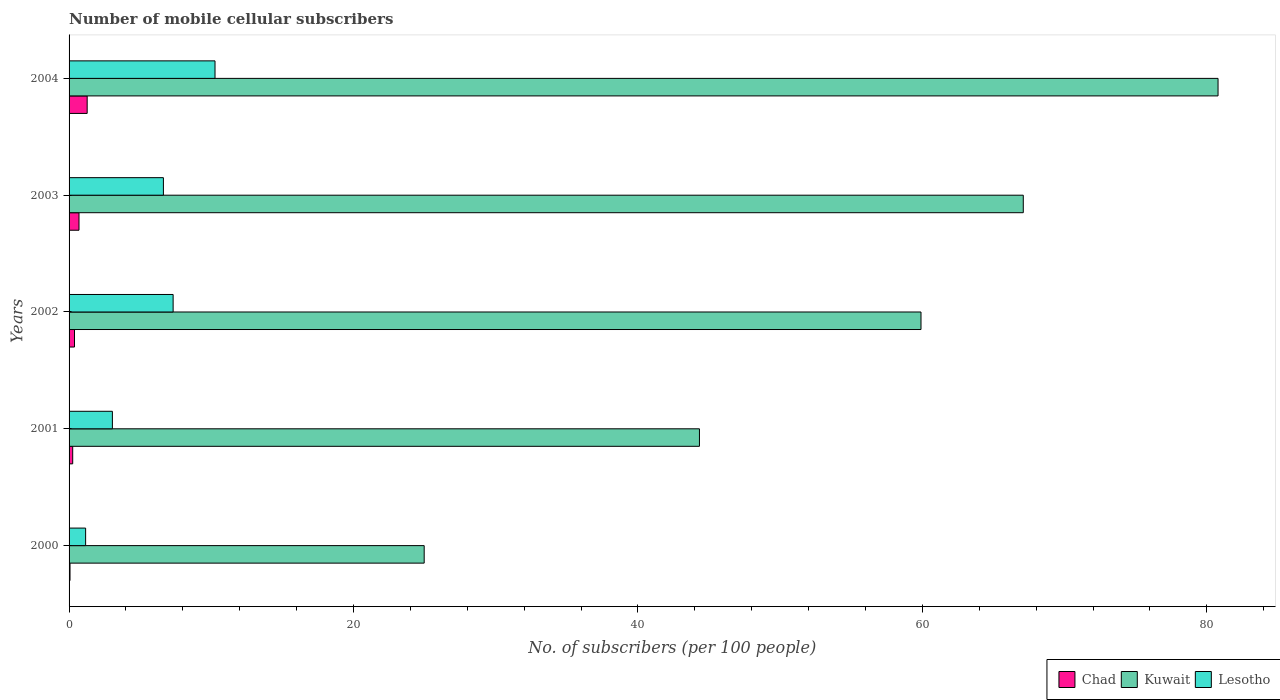How many groups of bars are there?
Offer a terse response. 5. Are the number of bars per tick equal to the number of legend labels?
Make the answer very short. Yes. Are the number of bars on each tick of the Y-axis equal?
Your response must be concise. Yes. How many bars are there on the 3rd tick from the top?
Your answer should be very brief. 3. How many bars are there on the 4th tick from the bottom?
Ensure brevity in your answer.  3. In how many cases, is the number of bars for a given year not equal to the number of legend labels?
Your response must be concise. 0. What is the number of mobile cellular subscribers in Chad in 2002?
Your response must be concise. 0.38. Across all years, what is the maximum number of mobile cellular subscribers in Kuwait?
Offer a terse response. 80.79. Across all years, what is the minimum number of mobile cellular subscribers in Lesotho?
Keep it short and to the point. 1.16. What is the total number of mobile cellular subscribers in Lesotho in the graph?
Provide a short and direct response. 28.42. What is the difference between the number of mobile cellular subscribers in Lesotho in 2000 and that in 2002?
Offer a terse response. -6.15. What is the difference between the number of mobile cellular subscribers in Kuwait in 2000 and the number of mobile cellular subscribers in Chad in 2003?
Make the answer very short. 24.27. What is the average number of mobile cellular subscribers in Chad per year?
Your response must be concise. 0.53. In the year 2003, what is the difference between the number of mobile cellular subscribers in Chad and number of mobile cellular subscribers in Lesotho?
Your response must be concise. -5.94. In how many years, is the number of mobile cellular subscribers in Lesotho greater than 8 ?
Make the answer very short. 1. What is the ratio of the number of mobile cellular subscribers in Lesotho in 2001 to that in 2003?
Provide a short and direct response. 0.46. Is the number of mobile cellular subscribers in Lesotho in 2002 less than that in 2004?
Provide a short and direct response. Yes. Is the difference between the number of mobile cellular subscribers in Chad in 2000 and 2004 greater than the difference between the number of mobile cellular subscribers in Lesotho in 2000 and 2004?
Keep it short and to the point. Yes. What is the difference between the highest and the second highest number of mobile cellular subscribers in Chad?
Your answer should be very brief. 0.57. What is the difference between the highest and the lowest number of mobile cellular subscribers in Chad?
Make the answer very short. 1.21. In how many years, is the number of mobile cellular subscribers in Kuwait greater than the average number of mobile cellular subscribers in Kuwait taken over all years?
Offer a very short reply. 3. What does the 2nd bar from the top in 2001 represents?
Your answer should be compact. Kuwait. What does the 2nd bar from the bottom in 2001 represents?
Ensure brevity in your answer.  Kuwait. Is it the case that in every year, the sum of the number of mobile cellular subscribers in Kuwait and number of mobile cellular subscribers in Chad is greater than the number of mobile cellular subscribers in Lesotho?
Give a very brief answer. Yes. Are all the bars in the graph horizontal?
Make the answer very short. Yes. Does the graph contain grids?
Offer a very short reply. No. How are the legend labels stacked?
Offer a very short reply. Horizontal. What is the title of the graph?
Your answer should be compact. Number of mobile cellular subscribers. What is the label or title of the X-axis?
Provide a succinct answer. No. of subscribers (per 100 people). What is the No. of subscribers (per 100 people) in Chad in 2000?
Offer a terse response. 0.07. What is the No. of subscribers (per 100 people) in Kuwait in 2000?
Provide a short and direct response. 24.97. What is the No. of subscribers (per 100 people) of Lesotho in 2000?
Provide a short and direct response. 1.16. What is the No. of subscribers (per 100 people) in Chad in 2001?
Offer a very short reply. 0.26. What is the No. of subscribers (per 100 people) in Kuwait in 2001?
Provide a short and direct response. 44.33. What is the No. of subscribers (per 100 people) in Lesotho in 2001?
Ensure brevity in your answer.  3.05. What is the No. of subscribers (per 100 people) of Chad in 2002?
Give a very brief answer. 0.38. What is the No. of subscribers (per 100 people) in Kuwait in 2002?
Give a very brief answer. 59.91. What is the No. of subscribers (per 100 people) in Lesotho in 2002?
Provide a succinct answer. 7.32. What is the No. of subscribers (per 100 people) in Chad in 2003?
Provide a short and direct response. 0.7. What is the No. of subscribers (per 100 people) in Kuwait in 2003?
Offer a terse response. 67.1. What is the No. of subscribers (per 100 people) in Lesotho in 2003?
Your response must be concise. 6.63. What is the No. of subscribers (per 100 people) in Chad in 2004?
Your answer should be very brief. 1.27. What is the No. of subscribers (per 100 people) in Kuwait in 2004?
Your answer should be very brief. 80.79. What is the No. of subscribers (per 100 people) in Lesotho in 2004?
Your answer should be compact. 10.26. Across all years, what is the maximum No. of subscribers (per 100 people) in Chad?
Your answer should be very brief. 1.27. Across all years, what is the maximum No. of subscribers (per 100 people) in Kuwait?
Ensure brevity in your answer.  80.79. Across all years, what is the maximum No. of subscribers (per 100 people) of Lesotho?
Offer a terse response. 10.26. Across all years, what is the minimum No. of subscribers (per 100 people) in Chad?
Offer a very short reply. 0.07. Across all years, what is the minimum No. of subscribers (per 100 people) of Kuwait?
Make the answer very short. 24.97. Across all years, what is the minimum No. of subscribers (per 100 people) in Lesotho?
Your answer should be compact. 1.16. What is the total No. of subscribers (per 100 people) in Chad in the graph?
Your answer should be very brief. 2.67. What is the total No. of subscribers (per 100 people) in Kuwait in the graph?
Make the answer very short. 277.09. What is the total No. of subscribers (per 100 people) in Lesotho in the graph?
Give a very brief answer. 28.42. What is the difference between the No. of subscribers (per 100 people) of Chad in 2000 and that in 2001?
Your answer should be very brief. -0.19. What is the difference between the No. of subscribers (per 100 people) of Kuwait in 2000 and that in 2001?
Keep it short and to the point. -19.36. What is the difference between the No. of subscribers (per 100 people) in Lesotho in 2000 and that in 2001?
Ensure brevity in your answer.  -1.88. What is the difference between the No. of subscribers (per 100 people) of Chad in 2000 and that in 2002?
Provide a succinct answer. -0.32. What is the difference between the No. of subscribers (per 100 people) of Kuwait in 2000 and that in 2002?
Offer a very short reply. -34.93. What is the difference between the No. of subscribers (per 100 people) in Lesotho in 2000 and that in 2002?
Provide a short and direct response. -6.15. What is the difference between the No. of subscribers (per 100 people) of Chad in 2000 and that in 2003?
Make the answer very short. -0.63. What is the difference between the No. of subscribers (per 100 people) in Kuwait in 2000 and that in 2003?
Give a very brief answer. -42.13. What is the difference between the No. of subscribers (per 100 people) in Lesotho in 2000 and that in 2003?
Keep it short and to the point. -5.47. What is the difference between the No. of subscribers (per 100 people) in Chad in 2000 and that in 2004?
Your answer should be very brief. -1.21. What is the difference between the No. of subscribers (per 100 people) of Kuwait in 2000 and that in 2004?
Provide a short and direct response. -55.82. What is the difference between the No. of subscribers (per 100 people) of Lesotho in 2000 and that in 2004?
Offer a very short reply. -9.1. What is the difference between the No. of subscribers (per 100 people) in Chad in 2001 and that in 2002?
Offer a terse response. -0.13. What is the difference between the No. of subscribers (per 100 people) in Kuwait in 2001 and that in 2002?
Give a very brief answer. -15.58. What is the difference between the No. of subscribers (per 100 people) in Lesotho in 2001 and that in 2002?
Provide a short and direct response. -4.27. What is the difference between the No. of subscribers (per 100 people) of Chad in 2001 and that in 2003?
Make the answer very short. -0.44. What is the difference between the No. of subscribers (per 100 people) of Kuwait in 2001 and that in 2003?
Provide a short and direct response. -22.77. What is the difference between the No. of subscribers (per 100 people) of Lesotho in 2001 and that in 2003?
Offer a very short reply. -3.59. What is the difference between the No. of subscribers (per 100 people) of Chad in 2001 and that in 2004?
Your response must be concise. -1.02. What is the difference between the No. of subscribers (per 100 people) in Kuwait in 2001 and that in 2004?
Offer a very short reply. -36.47. What is the difference between the No. of subscribers (per 100 people) in Lesotho in 2001 and that in 2004?
Give a very brief answer. -7.22. What is the difference between the No. of subscribers (per 100 people) of Chad in 2002 and that in 2003?
Give a very brief answer. -0.32. What is the difference between the No. of subscribers (per 100 people) of Kuwait in 2002 and that in 2003?
Make the answer very short. -7.19. What is the difference between the No. of subscribers (per 100 people) of Lesotho in 2002 and that in 2003?
Your response must be concise. 0.68. What is the difference between the No. of subscribers (per 100 people) in Chad in 2002 and that in 2004?
Your answer should be very brief. -0.89. What is the difference between the No. of subscribers (per 100 people) of Kuwait in 2002 and that in 2004?
Offer a terse response. -20.89. What is the difference between the No. of subscribers (per 100 people) in Lesotho in 2002 and that in 2004?
Your answer should be compact. -2.95. What is the difference between the No. of subscribers (per 100 people) of Chad in 2003 and that in 2004?
Make the answer very short. -0.57. What is the difference between the No. of subscribers (per 100 people) in Kuwait in 2003 and that in 2004?
Your answer should be very brief. -13.7. What is the difference between the No. of subscribers (per 100 people) in Lesotho in 2003 and that in 2004?
Offer a terse response. -3.63. What is the difference between the No. of subscribers (per 100 people) of Chad in 2000 and the No. of subscribers (per 100 people) of Kuwait in 2001?
Ensure brevity in your answer.  -44.26. What is the difference between the No. of subscribers (per 100 people) of Chad in 2000 and the No. of subscribers (per 100 people) of Lesotho in 2001?
Give a very brief answer. -2.98. What is the difference between the No. of subscribers (per 100 people) of Kuwait in 2000 and the No. of subscribers (per 100 people) of Lesotho in 2001?
Your answer should be very brief. 21.93. What is the difference between the No. of subscribers (per 100 people) in Chad in 2000 and the No. of subscribers (per 100 people) in Kuwait in 2002?
Ensure brevity in your answer.  -59.84. What is the difference between the No. of subscribers (per 100 people) in Chad in 2000 and the No. of subscribers (per 100 people) in Lesotho in 2002?
Ensure brevity in your answer.  -7.25. What is the difference between the No. of subscribers (per 100 people) in Kuwait in 2000 and the No. of subscribers (per 100 people) in Lesotho in 2002?
Offer a terse response. 17.65. What is the difference between the No. of subscribers (per 100 people) of Chad in 2000 and the No. of subscribers (per 100 people) of Kuwait in 2003?
Your answer should be compact. -67.03. What is the difference between the No. of subscribers (per 100 people) in Chad in 2000 and the No. of subscribers (per 100 people) in Lesotho in 2003?
Your answer should be compact. -6.57. What is the difference between the No. of subscribers (per 100 people) in Kuwait in 2000 and the No. of subscribers (per 100 people) in Lesotho in 2003?
Provide a short and direct response. 18.34. What is the difference between the No. of subscribers (per 100 people) of Chad in 2000 and the No. of subscribers (per 100 people) of Kuwait in 2004?
Make the answer very short. -80.73. What is the difference between the No. of subscribers (per 100 people) in Chad in 2000 and the No. of subscribers (per 100 people) in Lesotho in 2004?
Provide a succinct answer. -10.2. What is the difference between the No. of subscribers (per 100 people) of Kuwait in 2000 and the No. of subscribers (per 100 people) of Lesotho in 2004?
Provide a short and direct response. 14.71. What is the difference between the No. of subscribers (per 100 people) of Chad in 2001 and the No. of subscribers (per 100 people) of Kuwait in 2002?
Your answer should be very brief. -59.65. What is the difference between the No. of subscribers (per 100 people) of Chad in 2001 and the No. of subscribers (per 100 people) of Lesotho in 2002?
Keep it short and to the point. -7.06. What is the difference between the No. of subscribers (per 100 people) in Kuwait in 2001 and the No. of subscribers (per 100 people) in Lesotho in 2002?
Your answer should be very brief. 37.01. What is the difference between the No. of subscribers (per 100 people) in Chad in 2001 and the No. of subscribers (per 100 people) in Kuwait in 2003?
Your answer should be very brief. -66.84. What is the difference between the No. of subscribers (per 100 people) of Chad in 2001 and the No. of subscribers (per 100 people) of Lesotho in 2003?
Ensure brevity in your answer.  -6.38. What is the difference between the No. of subscribers (per 100 people) in Kuwait in 2001 and the No. of subscribers (per 100 people) in Lesotho in 2003?
Ensure brevity in your answer.  37.69. What is the difference between the No. of subscribers (per 100 people) of Chad in 2001 and the No. of subscribers (per 100 people) of Kuwait in 2004?
Ensure brevity in your answer.  -80.54. What is the difference between the No. of subscribers (per 100 people) in Chad in 2001 and the No. of subscribers (per 100 people) in Lesotho in 2004?
Your answer should be very brief. -10.01. What is the difference between the No. of subscribers (per 100 people) of Kuwait in 2001 and the No. of subscribers (per 100 people) of Lesotho in 2004?
Keep it short and to the point. 34.06. What is the difference between the No. of subscribers (per 100 people) in Chad in 2002 and the No. of subscribers (per 100 people) in Kuwait in 2003?
Your response must be concise. -66.71. What is the difference between the No. of subscribers (per 100 people) in Chad in 2002 and the No. of subscribers (per 100 people) in Lesotho in 2003?
Offer a terse response. -6.25. What is the difference between the No. of subscribers (per 100 people) of Kuwait in 2002 and the No. of subscribers (per 100 people) of Lesotho in 2003?
Your response must be concise. 53.27. What is the difference between the No. of subscribers (per 100 people) of Chad in 2002 and the No. of subscribers (per 100 people) of Kuwait in 2004?
Ensure brevity in your answer.  -80.41. What is the difference between the No. of subscribers (per 100 people) in Chad in 2002 and the No. of subscribers (per 100 people) in Lesotho in 2004?
Provide a short and direct response. -9.88. What is the difference between the No. of subscribers (per 100 people) in Kuwait in 2002 and the No. of subscribers (per 100 people) in Lesotho in 2004?
Offer a very short reply. 49.64. What is the difference between the No. of subscribers (per 100 people) in Chad in 2003 and the No. of subscribers (per 100 people) in Kuwait in 2004?
Keep it short and to the point. -80.09. What is the difference between the No. of subscribers (per 100 people) in Chad in 2003 and the No. of subscribers (per 100 people) in Lesotho in 2004?
Offer a very short reply. -9.56. What is the difference between the No. of subscribers (per 100 people) of Kuwait in 2003 and the No. of subscribers (per 100 people) of Lesotho in 2004?
Offer a very short reply. 56.83. What is the average No. of subscribers (per 100 people) in Chad per year?
Your response must be concise. 0.53. What is the average No. of subscribers (per 100 people) in Kuwait per year?
Make the answer very short. 55.42. What is the average No. of subscribers (per 100 people) in Lesotho per year?
Give a very brief answer. 5.68. In the year 2000, what is the difference between the No. of subscribers (per 100 people) in Chad and No. of subscribers (per 100 people) in Kuwait?
Offer a very short reply. -24.9. In the year 2000, what is the difference between the No. of subscribers (per 100 people) of Chad and No. of subscribers (per 100 people) of Lesotho?
Offer a very short reply. -1.1. In the year 2000, what is the difference between the No. of subscribers (per 100 people) in Kuwait and No. of subscribers (per 100 people) in Lesotho?
Your answer should be very brief. 23.81. In the year 2001, what is the difference between the No. of subscribers (per 100 people) of Chad and No. of subscribers (per 100 people) of Kuwait?
Make the answer very short. -44.07. In the year 2001, what is the difference between the No. of subscribers (per 100 people) in Chad and No. of subscribers (per 100 people) in Lesotho?
Provide a short and direct response. -2.79. In the year 2001, what is the difference between the No. of subscribers (per 100 people) in Kuwait and No. of subscribers (per 100 people) in Lesotho?
Your answer should be compact. 41.28. In the year 2002, what is the difference between the No. of subscribers (per 100 people) in Chad and No. of subscribers (per 100 people) in Kuwait?
Your response must be concise. -59.52. In the year 2002, what is the difference between the No. of subscribers (per 100 people) in Chad and No. of subscribers (per 100 people) in Lesotho?
Offer a very short reply. -6.93. In the year 2002, what is the difference between the No. of subscribers (per 100 people) of Kuwait and No. of subscribers (per 100 people) of Lesotho?
Keep it short and to the point. 52.59. In the year 2003, what is the difference between the No. of subscribers (per 100 people) in Chad and No. of subscribers (per 100 people) in Kuwait?
Your answer should be very brief. -66.4. In the year 2003, what is the difference between the No. of subscribers (per 100 people) of Chad and No. of subscribers (per 100 people) of Lesotho?
Give a very brief answer. -5.94. In the year 2003, what is the difference between the No. of subscribers (per 100 people) in Kuwait and No. of subscribers (per 100 people) in Lesotho?
Your answer should be compact. 60.46. In the year 2004, what is the difference between the No. of subscribers (per 100 people) in Chad and No. of subscribers (per 100 people) in Kuwait?
Offer a terse response. -79.52. In the year 2004, what is the difference between the No. of subscribers (per 100 people) of Chad and No. of subscribers (per 100 people) of Lesotho?
Make the answer very short. -8.99. In the year 2004, what is the difference between the No. of subscribers (per 100 people) in Kuwait and No. of subscribers (per 100 people) in Lesotho?
Give a very brief answer. 70.53. What is the ratio of the No. of subscribers (per 100 people) of Chad in 2000 to that in 2001?
Make the answer very short. 0.26. What is the ratio of the No. of subscribers (per 100 people) of Kuwait in 2000 to that in 2001?
Make the answer very short. 0.56. What is the ratio of the No. of subscribers (per 100 people) in Lesotho in 2000 to that in 2001?
Your answer should be very brief. 0.38. What is the ratio of the No. of subscribers (per 100 people) of Chad in 2000 to that in 2002?
Your answer should be compact. 0.17. What is the ratio of the No. of subscribers (per 100 people) in Kuwait in 2000 to that in 2002?
Offer a very short reply. 0.42. What is the ratio of the No. of subscribers (per 100 people) of Lesotho in 2000 to that in 2002?
Offer a terse response. 0.16. What is the ratio of the No. of subscribers (per 100 people) of Chad in 2000 to that in 2003?
Provide a short and direct response. 0.09. What is the ratio of the No. of subscribers (per 100 people) in Kuwait in 2000 to that in 2003?
Give a very brief answer. 0.37. What is the ratio of the No. of subscribers (per 100 people) of Lesotho in 2000 to that in 2003?
Offer a very short reply. 0.18. What is the ratio of the No. of subscribers (per 100 people) in Chad in 2000 to that in 2004?
Make the answer very short. 0.05. What is the ratio of the No. of subscribers (per 100 people) of Kuwait in 2000 to that in 2004?
Make the answer very short. 0.31. What is the ratio of the No. of subscribers (per 100 people) in Lesotho in 2000 to that in 2004?
Your response must be concise. 0.11. What is the ratio of the No. of subscribers (per 100 people) in Chad in 2001 to that in 2002?
Your answer should be compact. 0.67. What is the ratio of the No. of subscribers (per 100 people) in Kuwait in 2001 to that in 2002?
Your response must be concise. 0.74. What is the ratio of the No. of subscribers (per 100 people) of Lesotho in 2001 to that in 2002?
Keep it short and to the point. 0.42. What is the ratio of the No. of subscribers (per 100 people) of Chad in 2001 to that in 2003?
Ensure brevity in your answer.  0.37. What is the ratio of the No. of subscribers (per 100 people) of Kuwait in 2001 to that in 2003?
Your answer should be very brief. 0.66. What is the ratio of the No. of subscribers (per 100 people) of Lesotho in 2001 to that in 2003?
Offer a very short reply. 0.46. What is the ratio of the No. of subscribers (per 100 people) of Chad in 2001 to that in 2004?
Provide a succinct answer. 0.2. What is the ratio of the No. of subscribers (per 100 people) in Kuwait in 2001 to that in 2004?
Your response must be concise. 0.55. What is the ratio of the No. of subscribers (per 100 people) of Lesotho in 2001 to that in 2004?
Ensure brevity in your answer.  0.3. What is the ratio of the No. of subscribers (per 100 people) of Chad in 2002 to that in 2003?
Make the answer very short. 0.55. What is the ratio of the No. of subscribers (per 100 people) in Kuwait in 2002 to that in 2003?
Keep it short and to the point. 0.89. What is the ratio of the No. of subscribers (per 100 people) of Lesotho in 2002 to that in 2003?
Your answer should be very brief. 1.1. What is the ratio of the No. of subscribers (per 100 people) in Chad in 2002 to that in 2004?
Make the answer very short. 0.3. What is the ratio of the No. of subscribers (per 100 people) in Kuwait in 2002 to that in 2004?
Your answer should be compact. 0.74. What is the ratio of the No. of subscribers (per 100 people) in Lesotho in 2002 to that in 2004?
Your response must be concise. 0.71. What is the ratio of the No. of subscribers (per 100 people) in Chad in 2003 to that in 2004?
Give a very brief answer. 0.55. What is the ratio of the No. of subscribers (per 100 people) in Kuwait in 2003 to that in 2004?
Make the answer very short. 0.83. What is the ratio of the No. of subscribers (per 100 people) in Lesotho in 2003 to that in 2004?
Make the answer very short. 0.65. What is the difference between the highest and the second highest No. of subscribers (per 100 people) in Chad?
Make the answer very short. 0.57. What is the difference between the highest and the second highest No. of subscribers (per 100 people) in Kuwait?
Give a very brief answer. 13.7. What is the difference between the highest and the second highest No. of subscribers (per 100 people) in Lesotho?
Provide a short and direct response. 2.95. What is the difference between the highest and the lowest No. of subscribers (per 100 people) in Chad?
Ensure brevity in your answer.  1.21. What is the difference between the highest and the lowest No. of subscribers (per 100 people) in Kuwait?
Give a very brief answer. 55.82. What is the difference between the highest and the lowest No. of subscribers (per 100 people) of Lesotho?
Ensure brevity in your answer.  9.1. 